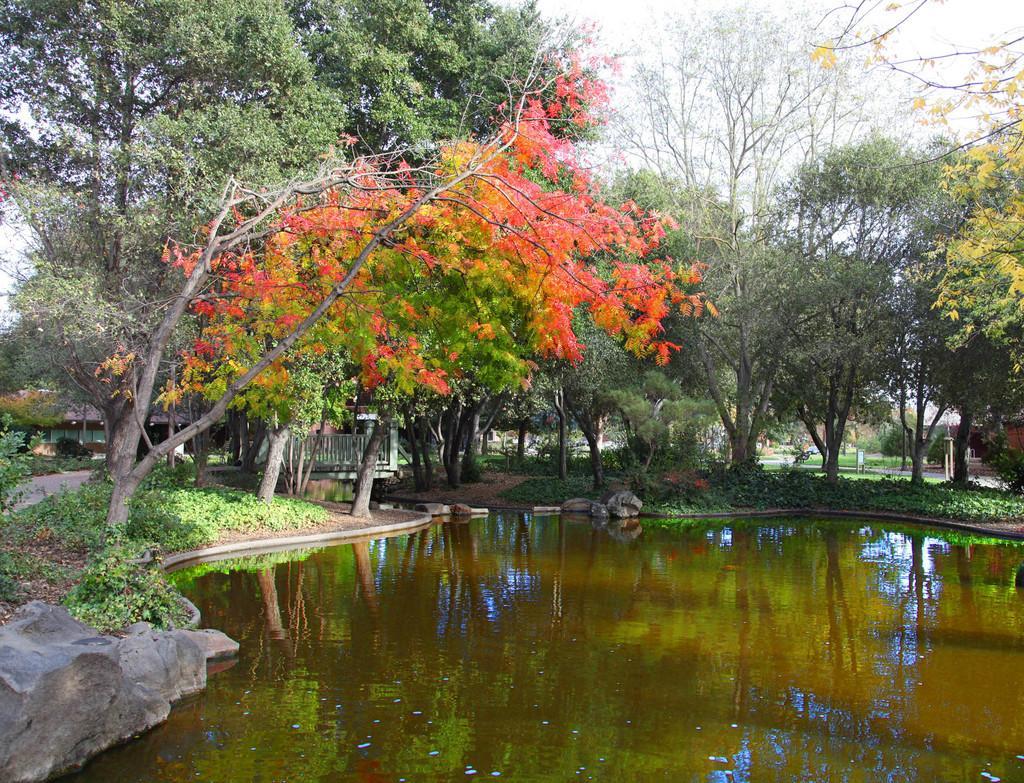In one or two sentences, can you explain what this image depicts? In this image we can see a lake, stones, grass, trees, shed, wooden grills, buildings and sky. 